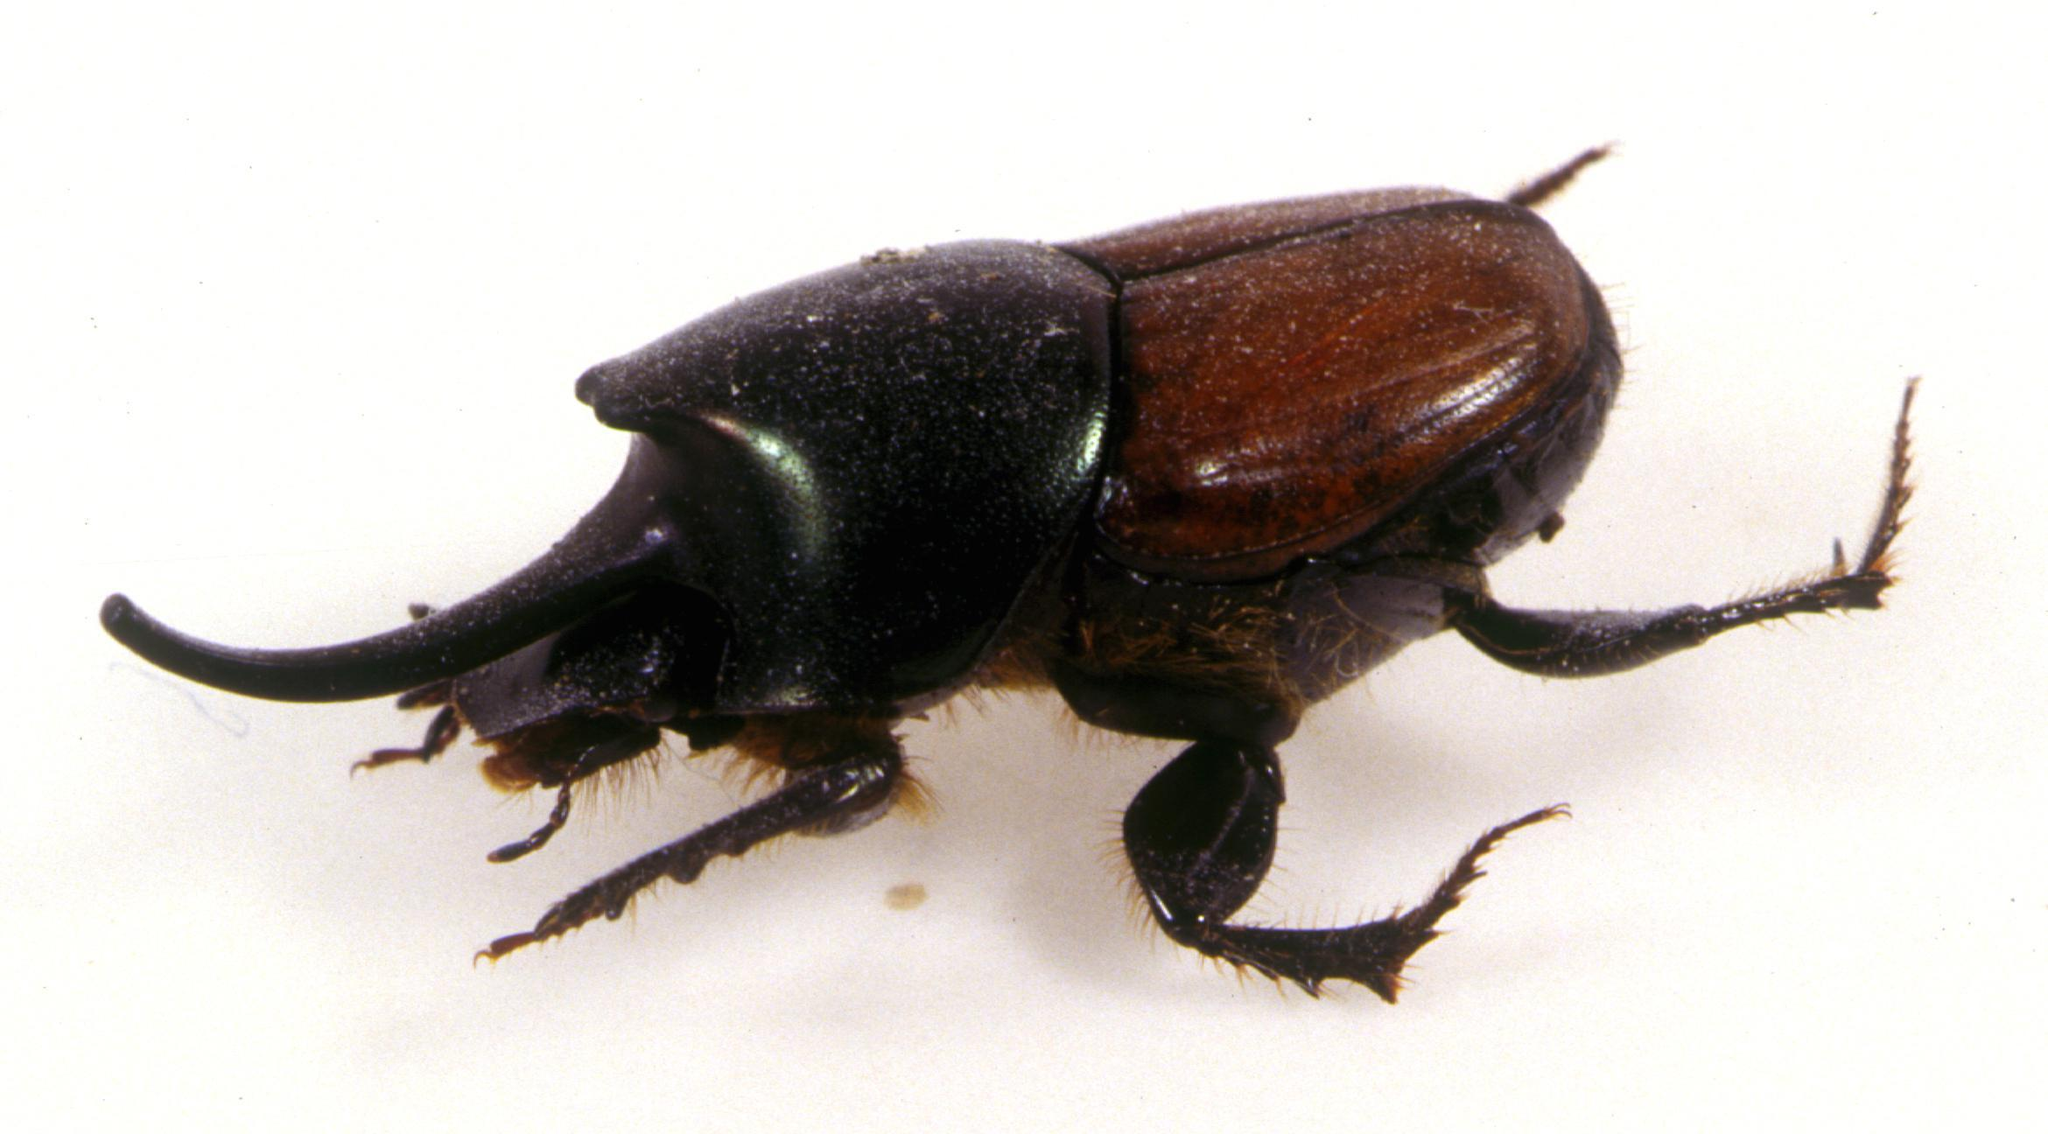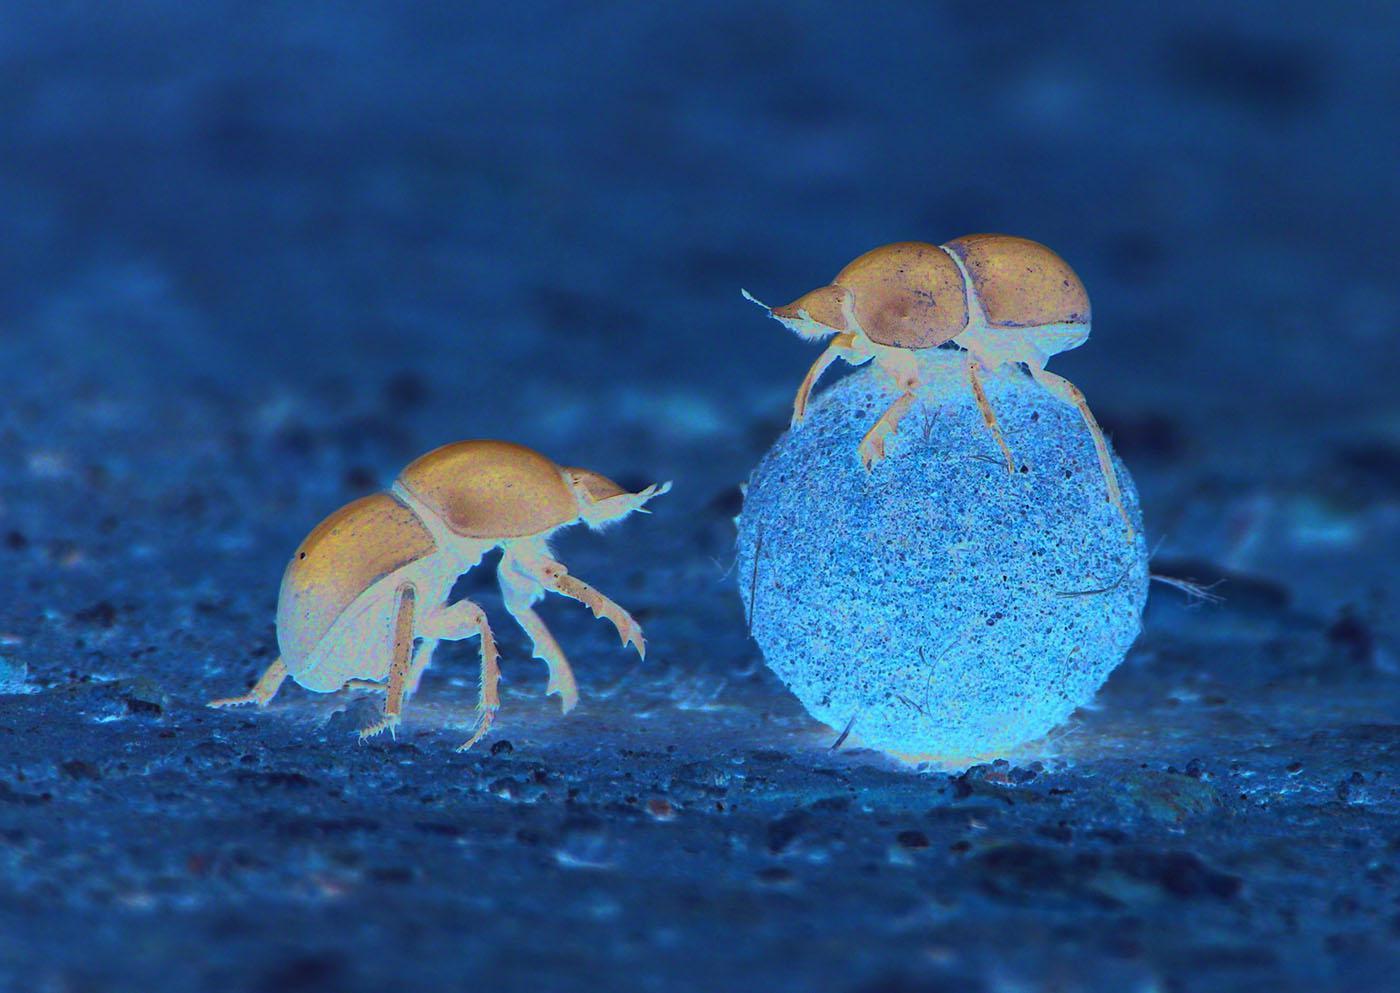The first image is the image on the left, the second image is the image on the right. Given the left and right images, does the statement "Left image shows one left-facing beetle with no dungball." hold true? Answer yes or no. Yes. The first image is the image on the left, the second image is the image on the right. Evaluate the accuracy of this statement regarding the images: "There are two insects touching the ball in the image on the right". Is it true? Answer yes or no. No. 